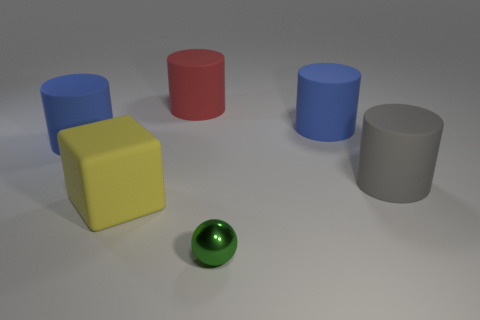Subtract all red cylinders. How many cylinders are left? 3 Add 1 tiny purple matte blocks. How many objects exist? 7 Subtract 0 purple blocks. How many objects are left? 6 Subtract all cylinders. How many objects are left? 2 Subtract all tiny gray shiny balls. Subtract all gray things. How many objects are left? 5 Add 2 big red objects. How many big red objects are left? 3 Add 5 big blue cylinders. How many big blue cylinders exist? 7 